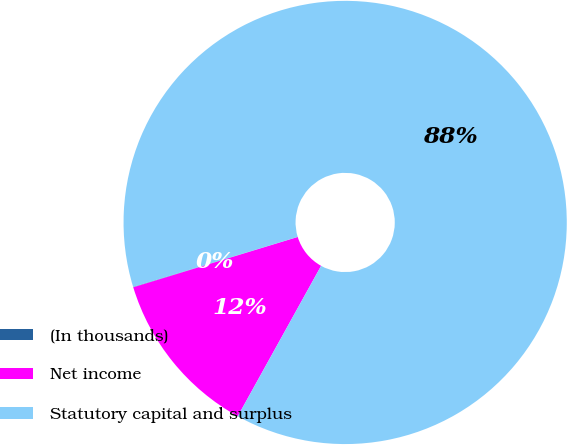Convert chart to OTSL. <chart><loc_0><loc_0><loc_500><loc_500><pie_chart><fcel>(In thousands)<fcel>Net income<fcel>Statutory capital and surplus<nl><fcel>0.03%<fcel>12.22%<fcel>87.75%<nl></chart> 